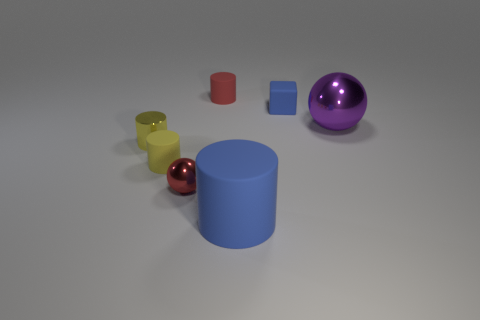What is the size of the blue rubber object that is the same shape as the yellow metal object? The blue rubber object appears to be considerably larger than the yellow metal object. Although they share the same cylindrical shape, the blue rubber object's dimensions are approximately twice as large in both height and diameter. 